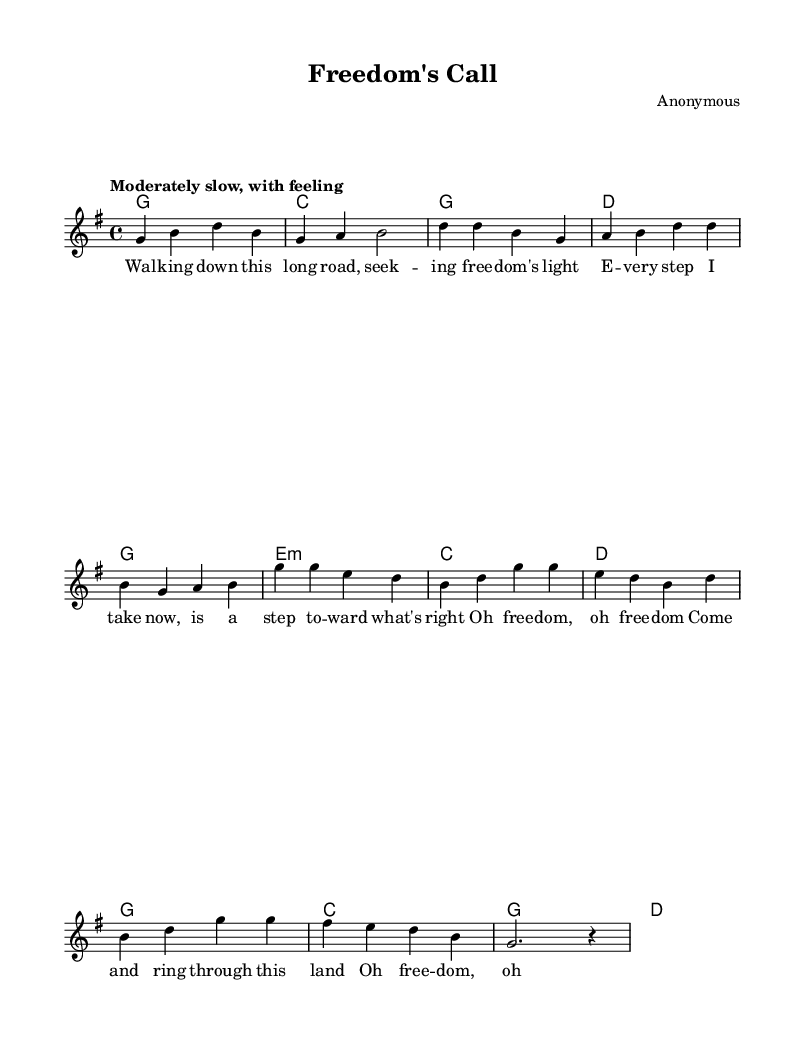What is the title of this piece? The title is indicated at the top of the sheet music in the header. It reads "Freedom's Call."
Answer: Freedom's Call What is the key signature of this music? The key signature is determined by looking for the sharp or flat symbols at the beginning of the staff. In this case, no sharps or flats are present, indicating G major.
Answer: G major What is the time signature of this piece? The time signature is shown as two numbers at the beginning of the staff. Here, it shows 4 over 4, meaning there are four beats per measure.
Answer: 4/4 What is the tempo marking for this music? The tempo marking is indicated in the global section of the code, stating "Moderately slow, with feeling," which reflects the intended speed and expression.
Answer: Moderately slow How many measures are there in the verse section? By counting the measure bars in the verse section found in the voice part, it is evident that there are four measures presented.
Answer: 4 Which chord is the first in the chorus? The first chord of the chorus, derived from the harmonies section, is G, indicated at the start of that section.
Answer: G What is the lyrical theme of the piece? The lyrics discuss themes of seeking freedom and justice, illustrated by phrases like "seeking freedom's light" and "Justice, take my hand."
Answer: Freedom and justice 